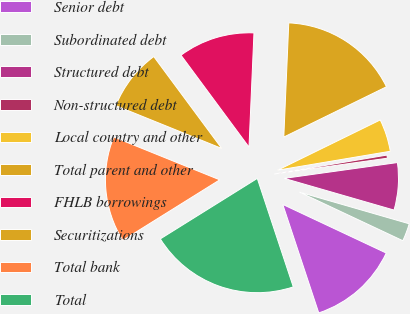Convert chart. <chart><loc_0><loc_0><loc_500><loc_500><pie_chart><fcel>Senior debt<fcel>Subordinated debt<fcel>Structured debt<fcel>Non-structured debt<fcel>Local country and other<fcel>Total parent and other<fcel>FHLB borrowings<fcel>Securitizations<fcel>Total bank<fcel>Total<nl><fcel>12.91%<fcel>2.52%<fcel>6.68%<fcel>0.44%<fcel>4.6%<fcel>17.06%<fcel>10.83%<fcel>8.75%<fcel>14.99%<fcel>21.22%<nl></chart> 